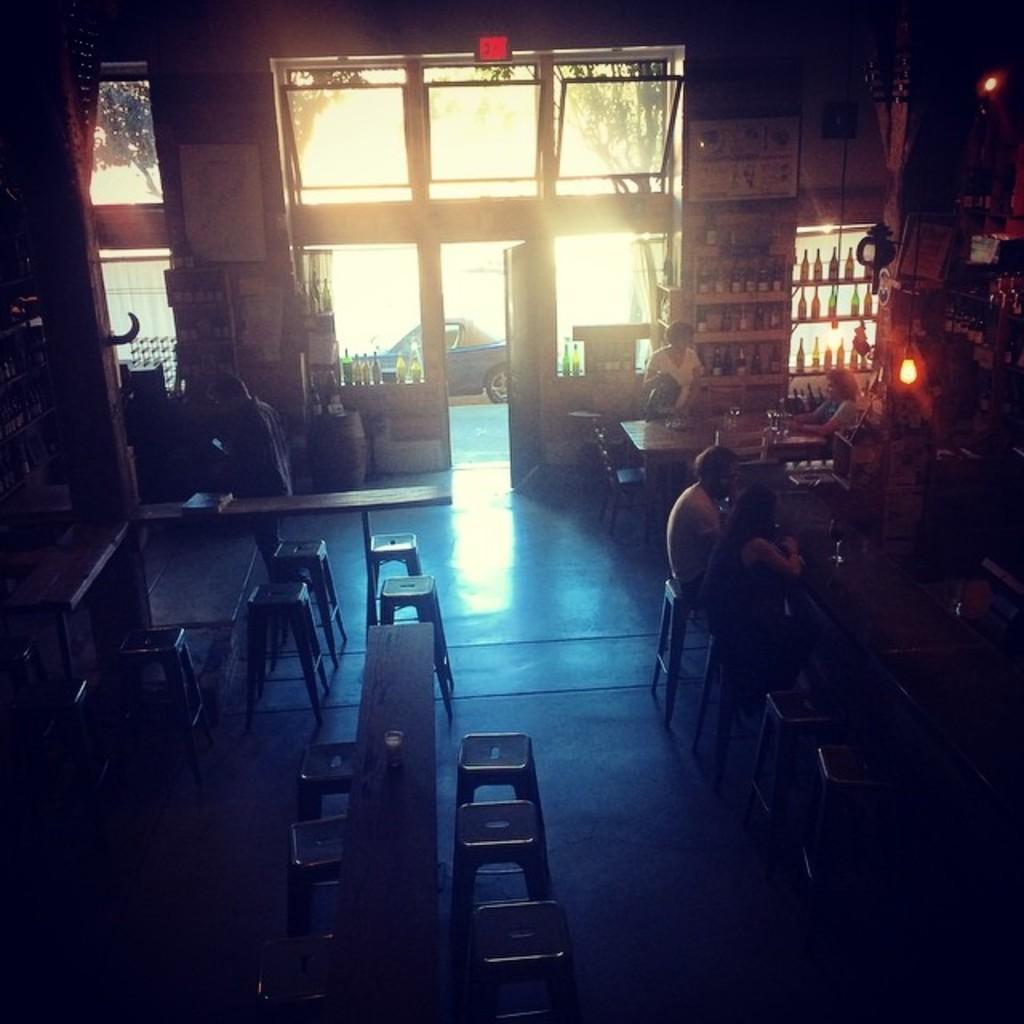Could you give a brief overview of what you see in this image? The picture is captured inside restaurant there are many stools and benches, few people sitting on the stools and in the background there are plenty of alcohol bottles kept in the shelves, on the left side there is a door and some windows. Outside the door there is a car. 